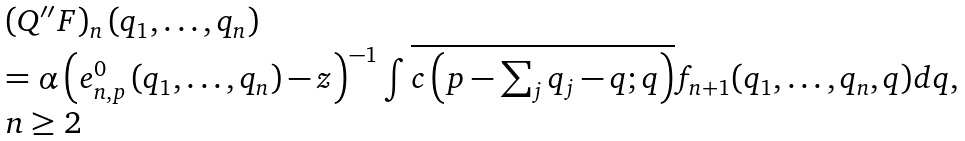<formula> <loc_0><loc_0><loc_500><loc_500>\begin{array} { l } \left ( Q ^ { \prime \prime } F \right ) _ { n } \left ( q _ { 1 } , \dots , q _ { n } \right ) \\ = \alpha \left ( e _ { n , p } ^ { 0 } \left ( q _ { 1 } , \dots , q _ { n } \right ) - z \right ) ^ { - 1 } \int \overline { c \left ( p - \sum _ { j } q _ { j } - q ; q \right ) } f _ { n + 1 } ( q _ { 1 } , \dots , q _ { n } , q ) d q , \\ n \geq 2 \end{array}</formula> 